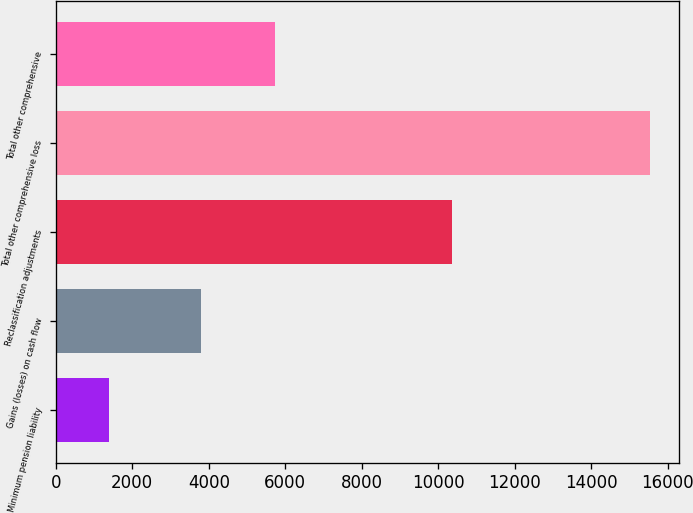Convert chart. <chart><loc_0><loc_0><loc_500><loc_500><bar_chart><fcel>Minimum pension liability<fcel>Gains (losses) on cash flow<fcel>Reclassification adjustments<fcel>Total other comprehensive loss<fcel>Total other comprehensive<nl><fcel>1386<fcel>3791<fcel>10348<fcel>15525<fcel>5735<nl></chart> 